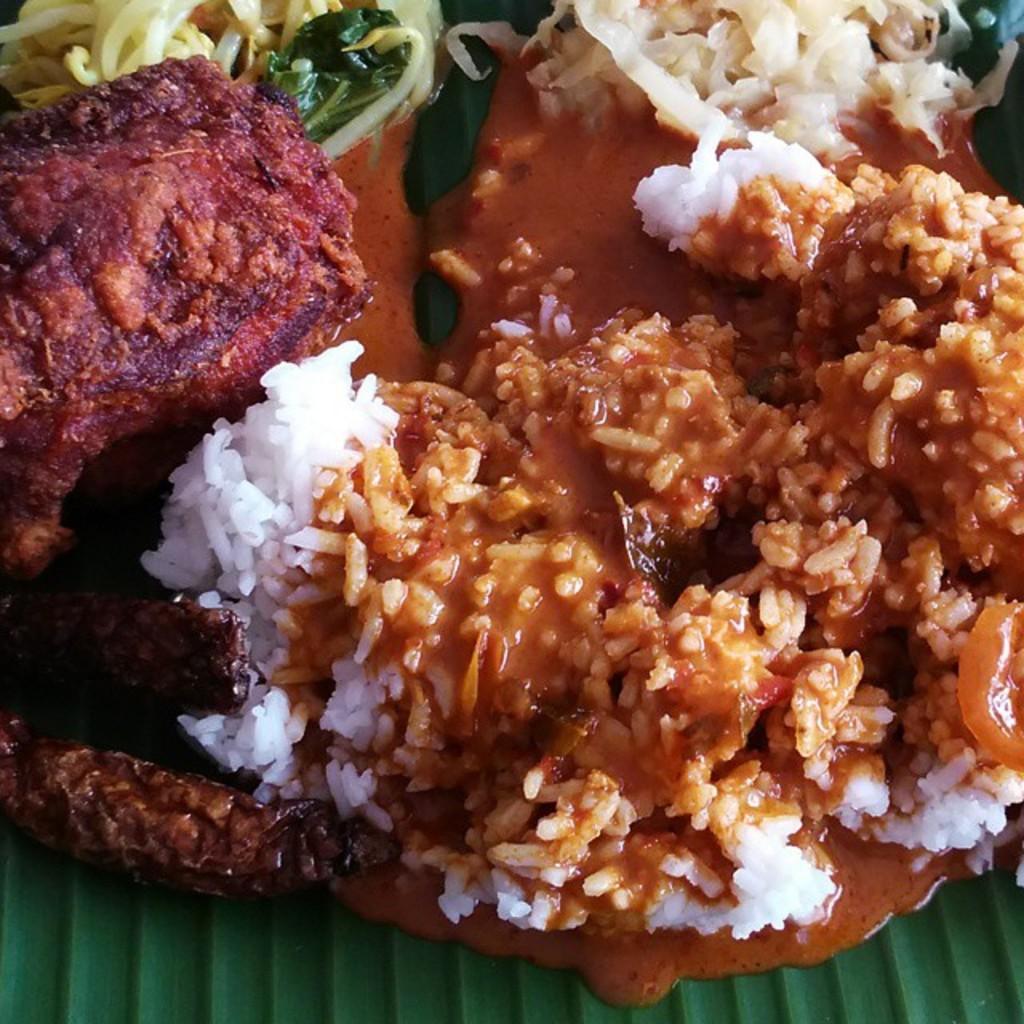Describe this image in one or two sentences. In this image we can see some food items on the green colored surface. 